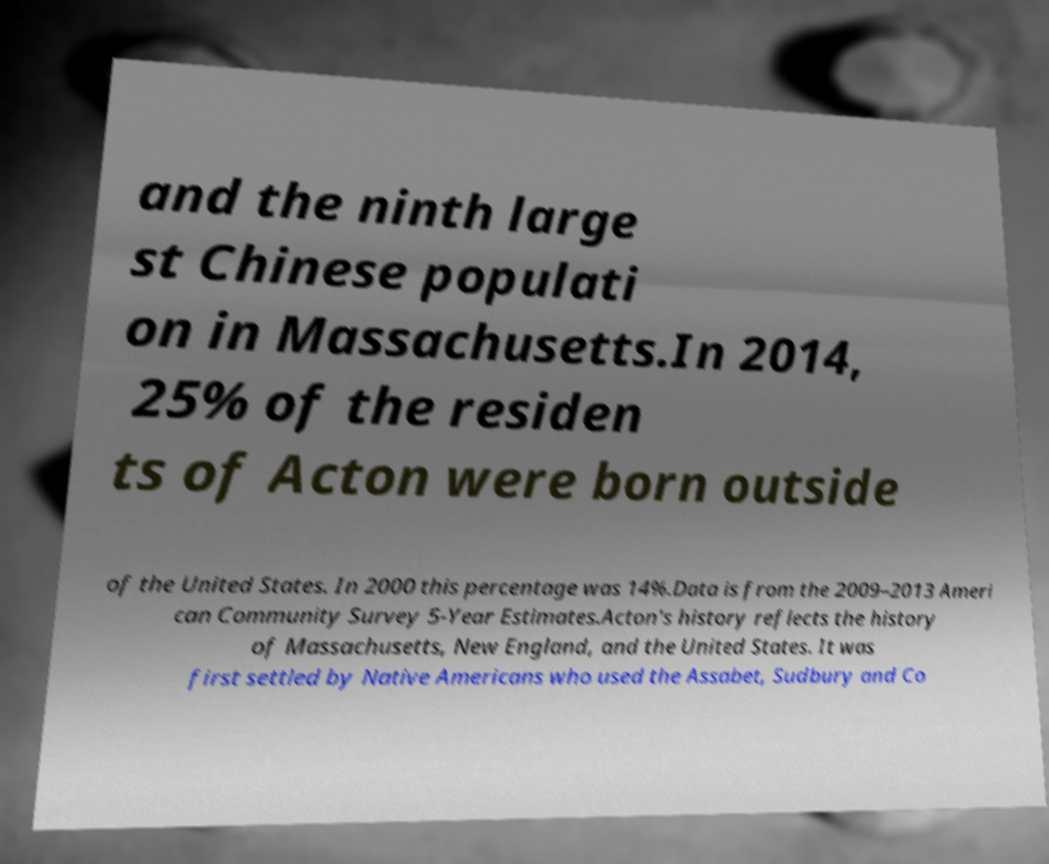What messages or text are displayed in this image? I need them in a readable, typed format. and the ninth large st Chinese populati on in Massachusetts.In 2014, 25% of the residen ts of Acton were born outside of the United States. In 2000 this percentage was 14%.Data is from the 2009–2013 Ameri can Community Survey 5-Year Estimates.Acton's history reflects the history of Massachusetts, New England, and the United States. It was first settled by Native Americans who used the Assabet, Sudbury and Co 